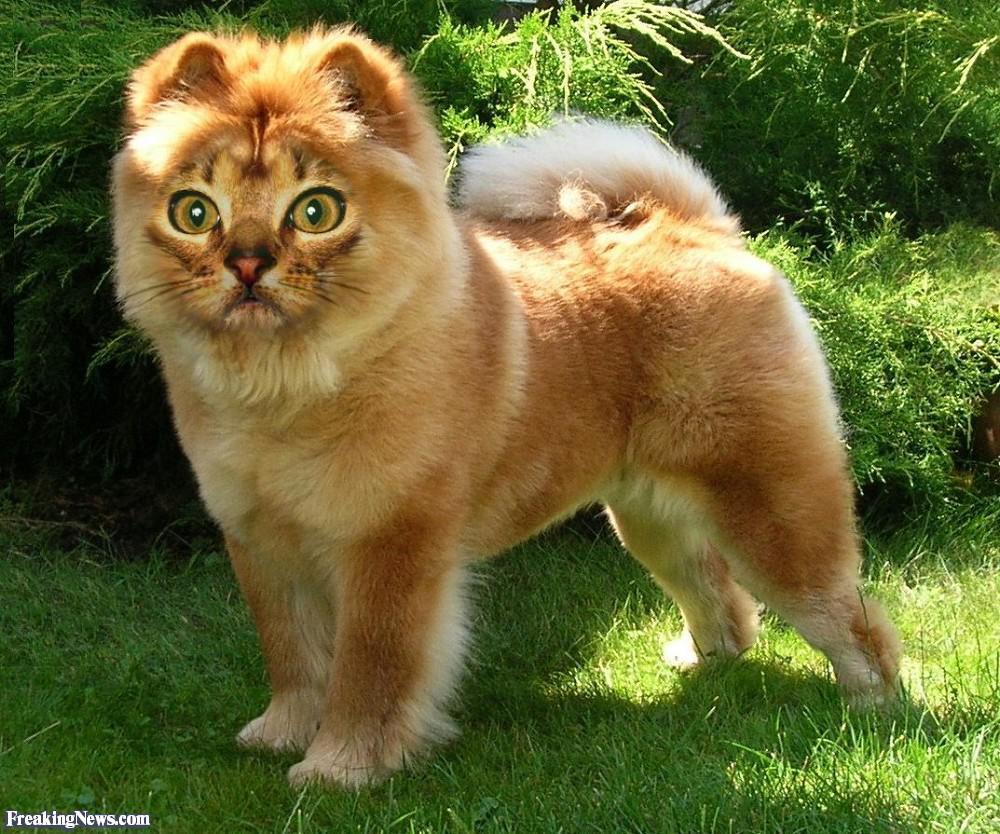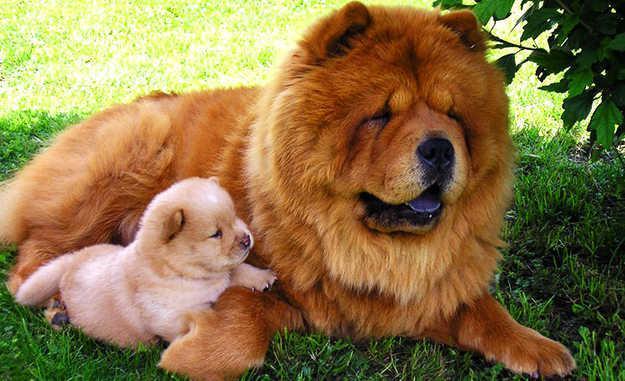The first image is the image on the left, the second image is the image on the right. Given the left and right images, does the statement "One of the images only shows the head of a dog." hold true? Answer yes or no. No. 